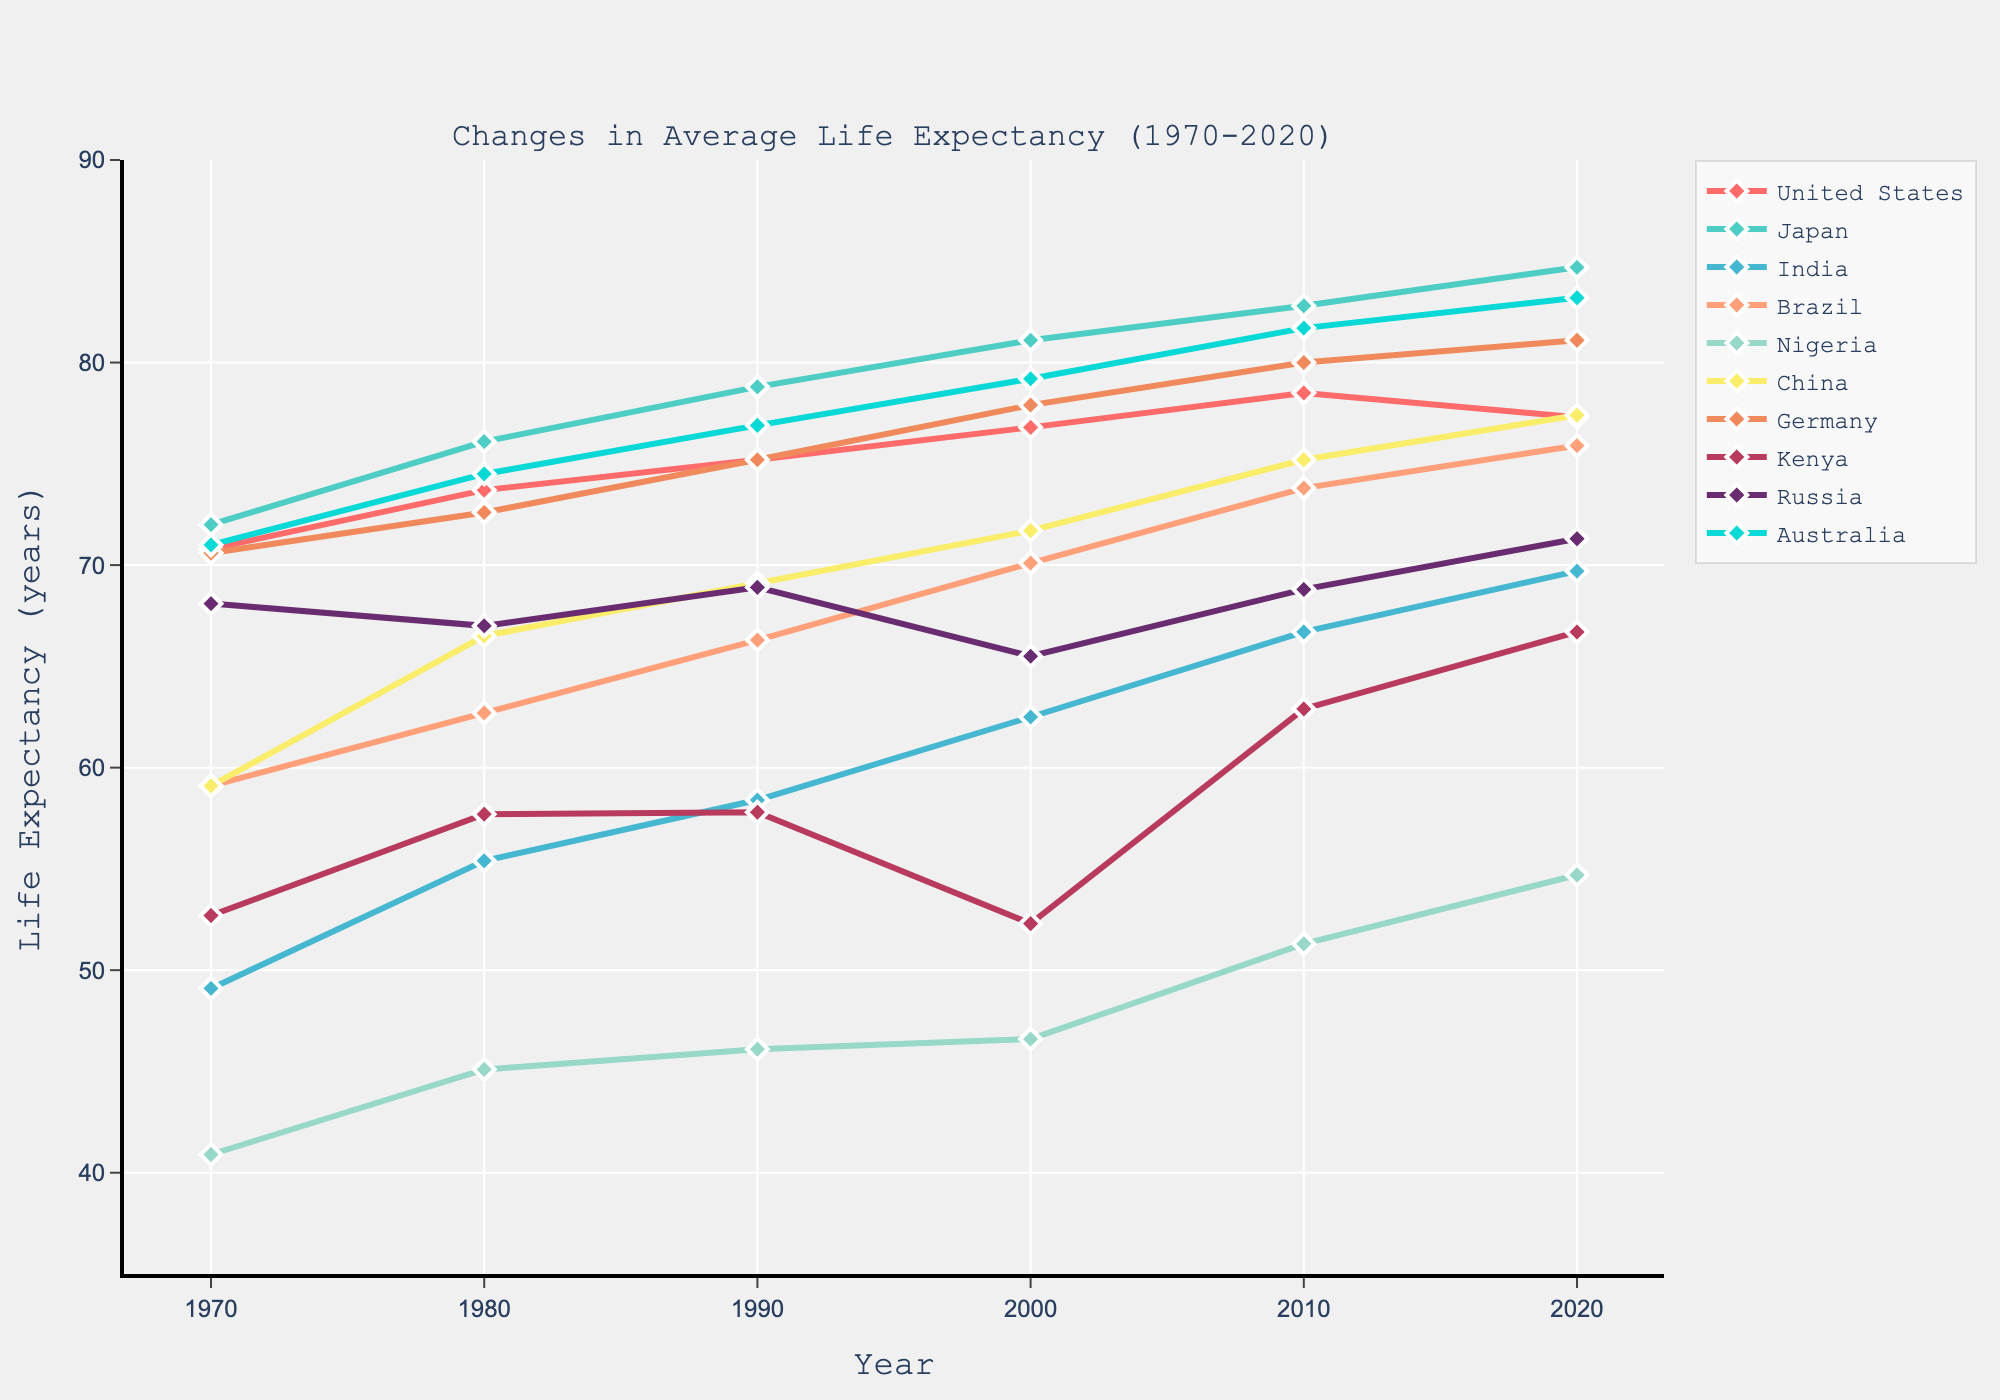Which country had the highest life expectancy in 2020? By inspecting the end of each line, we identify that Japan had the highest life expectancy in 2020.
Answer: Japan What is the difference in life expectancy between Japan and Nigeria in 2020? Subtract the life expectancy of Nigeria in 2020 (54.7) from that of Japan (84.7). 84.7 - 54.7 = 30.
Answer: 30 years Between 1970 and 2020, which country showed the smallest increase in life expectancy? Calculate the difference between 2020 and 1970 for each country. Nigeria had the smallest increase (54.7 - 40.9 = 13.8).
Answer: Nigeria In which decade did China have the most significant increase in life expectancy? Compare the differences in life expectancy for each decade for China: 1980-1970 (7.4), 1990-1980 (2.6), 2000-1990 (2.6), 2010-2000 (3.5), 2020-2010 (2.2). The increase of 7.4 in the 1970s is the largest.
Answer: 1970s Which country had a decrease in life expectancy between any two decades, and during which period did this happen? Russia had a decrease between 1980 (67.0) and 1990 (68.9) and 2000 (65.5). Also, Kenya had a decline from 1990 (57.8) to 2000 (52.3).
Answer: Russia (2000-1990) and Kenya (2000-1990) Which countries experienced an increase in life expectancy of over 10 years from 2000 to 2020? For each country, calculate the difference from 2020 and 2000. Brazil (75.9 - 70.1 = 5.8), China (77.4 - 71.7 = 5.7), Germany (81.1 - 77.9 = 3.2), Kenya (66.7 - 52.3 = 14.4), and Nigeria (54.7 - 46.6 = 8.1) made such an increase. Thus, only Kenya increased by over 10 years.
Answer: Kenya What is the average life expectancy of all countries in 2010? Sum all life expectancy values for 2010 and divide the total by the number of countries: (78.5+82.8+66.7+73.8+51.3+75.2+80.0+62.9+68.8+81.7)/10 = 72.17.
Answer: 72.17 years Which country shows a continuous upward trend in life expectancy from 1970 to 2020? By inspecting the data, Japan and Australia show continuous increases across all decades.
Answer: Japan and Australia 